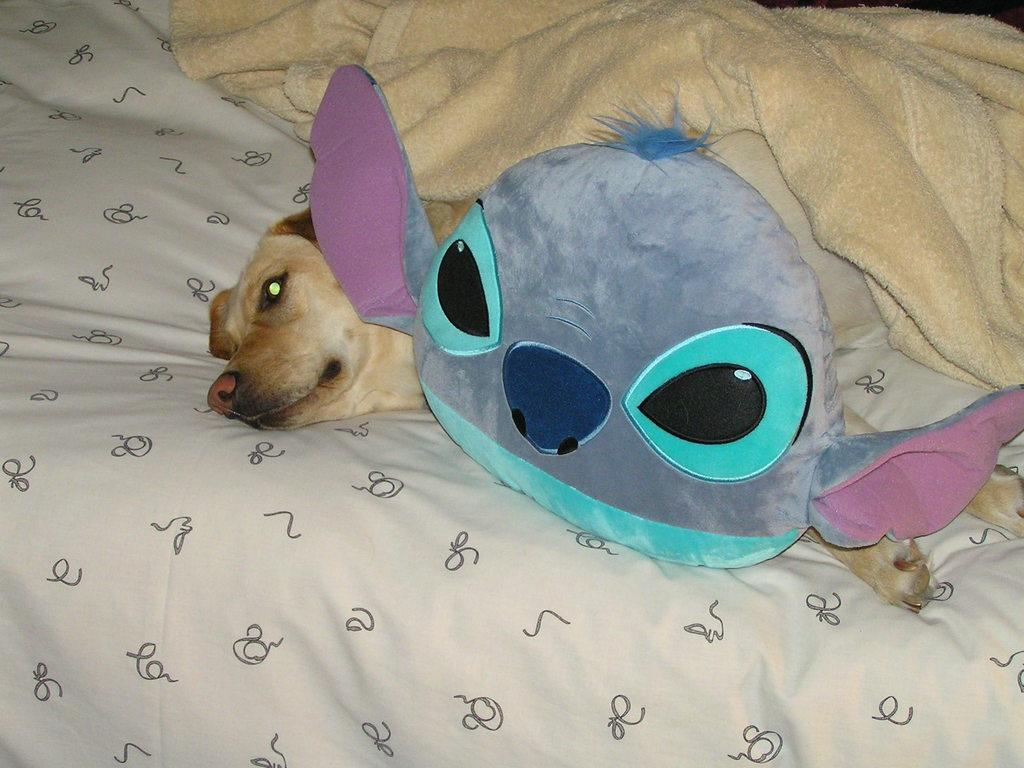What type of animal can be seen in the image? There is a dog in the image. What other object is present in the image? There is a toy in the image. Where is the blanket located in the image? The blanket is on a bed in the image. How many brothers are playing with the dog in the image? There are no brothers present in the image; it only features a dog and a toy. What type of hen can be seen interacting with the toy in the image? There is no hen present in the image; it only features a dog and a toy. 